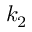Convert formula to latex. <formula><loc_0><loc_0><loc_500><loc_500>k _ { 2 }</formula> 